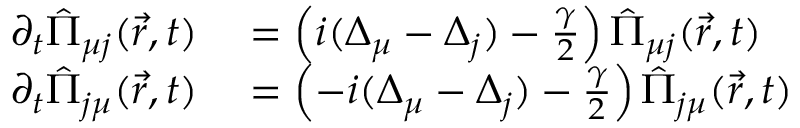<formula> <loc_0><loc_0><loc_500><loc_500>\begin{array} { r l } { \partial _ { t } \hat { \Pi } _ { \mu j } ( \vec { r } , t ) } & = \left ( i ( \Delta _ { \mu } - \Delta _ { j } ) - \frac { \gamma } { 2 } \right ) \hat { \Pi } _ { \mu j } ( \vec { r } , t ) } \\ { \partial _ { t } \hat { \Pi } _ { j \mu } ( \vec { r } , t ) } & = \left ( - i ( \Delta _ { \mu } - \Delta _ { j } ) - \frac { \gamma } { 2 } \right ) \hat { \Pi } _ { j \mu } ( \vec { r } , t ) } \end{array}</formula> 